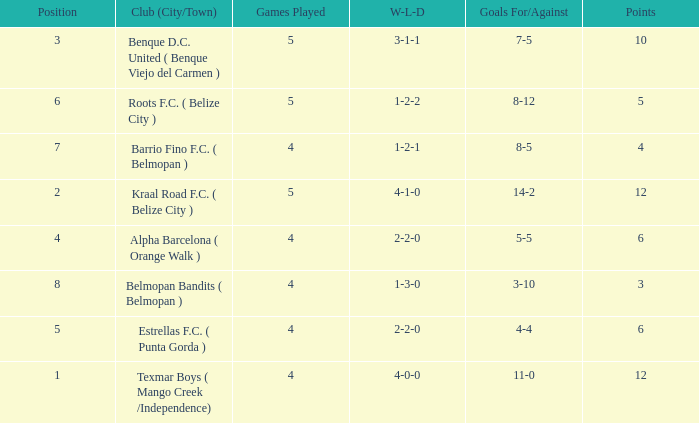What is the minimum points with goals for/against being 8-5 4.0. 